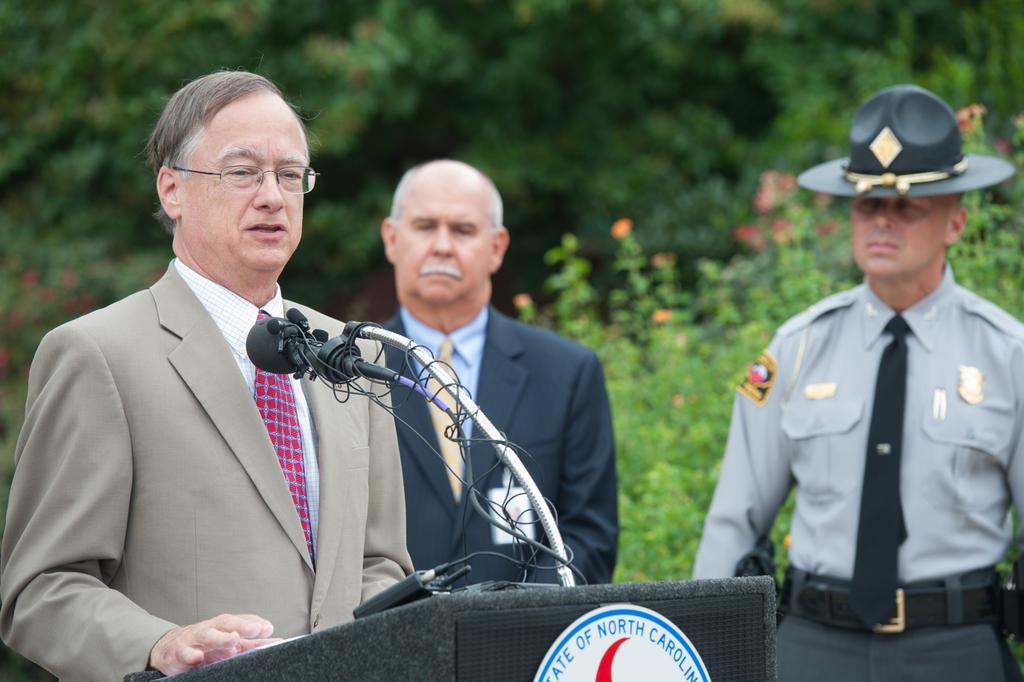In one or two sentences, can you explain what this image depicts? This is the man standing near the podium. These are the mikes. There are two people standing. In the background, I can see the trees and the plants with the flowers. 